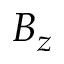Convert formula to latex. <formula><loc_0><loc_0><loc_500><loc_500>B _ { z }</formula> 